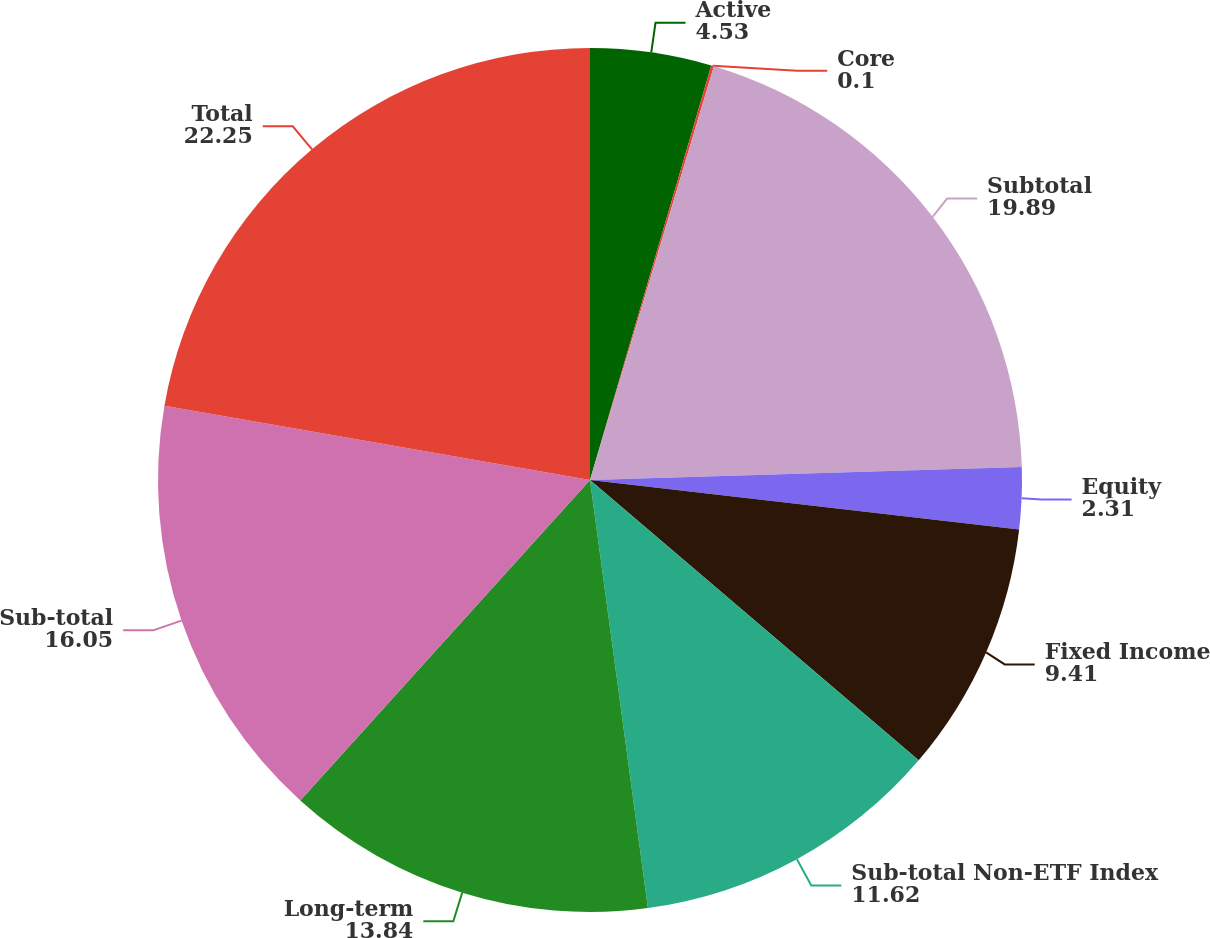<chart> <loc_0><loc_0><loc_500><loc_500><pie_chart><fcel>Active<fcel>Core<fcel>Subtotal<fcel>Equity<fcel>Fixed Income<fcel>Sub-total Non-ETF Index<fcel>Long-term<fcel>Sub-total<fcel>Total<nl><fcel>4.53%<fcel>0.1%<fcel>19.89%<fcel>2.31%<fcel>9.41%<fcel>11.62%<fcel>13.84%<fcel>16.05%<fcel>22.25%<nl></chart> 